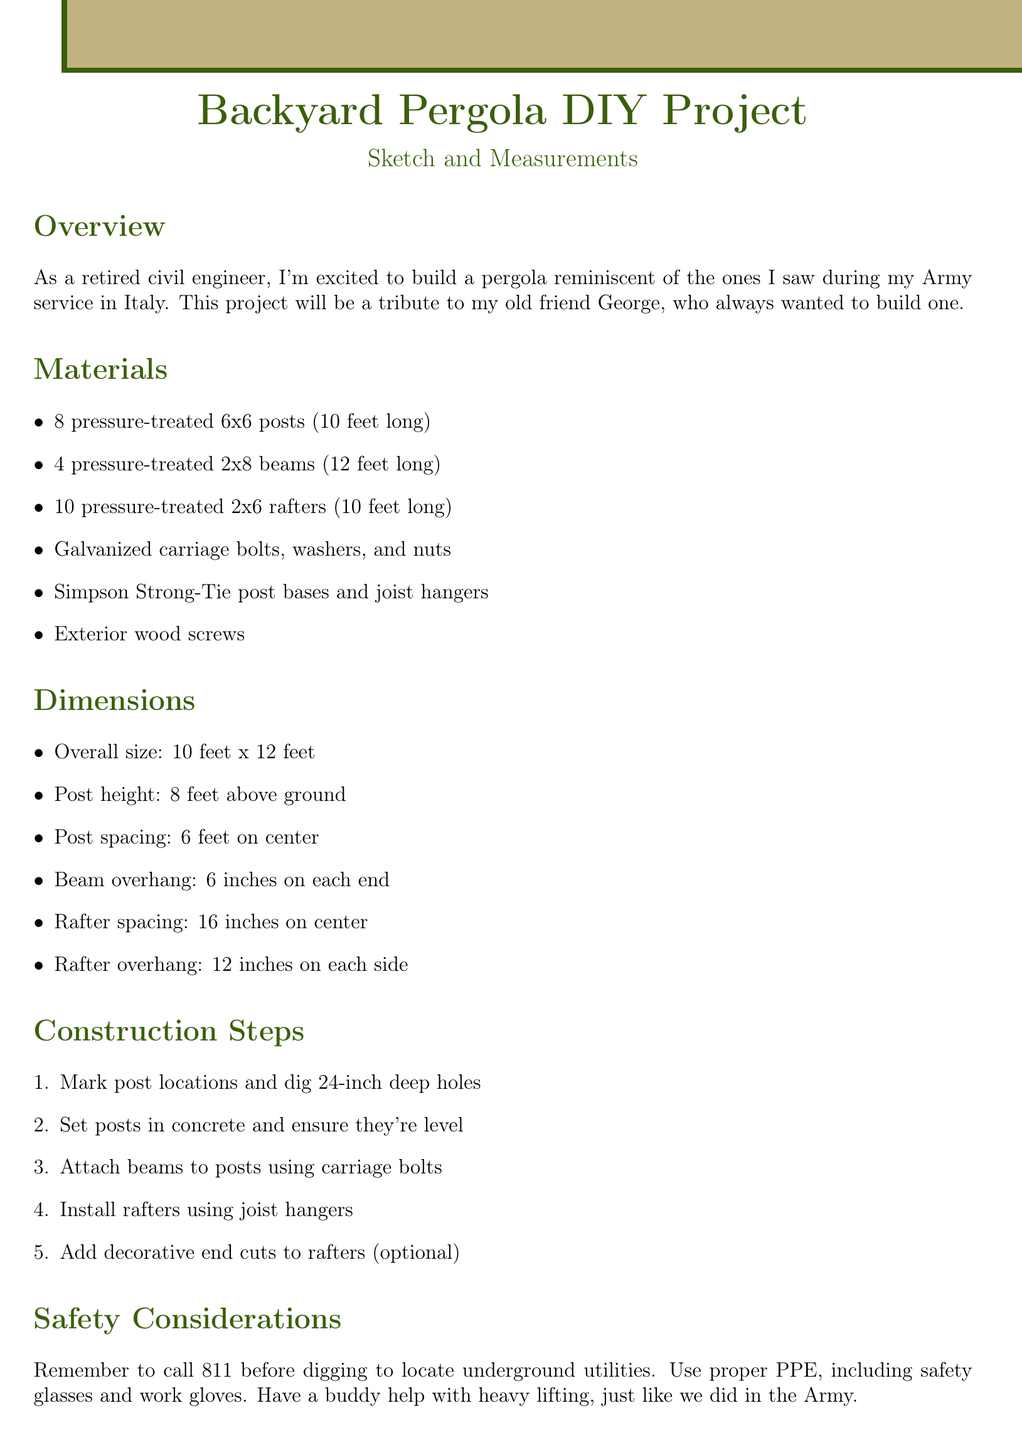What is the tribute in this project? The project is a tribute to the old friend George, who always wanted to build a pergola.
Answer: George How many posts are needed for the pergola? The document states the need for 8 pressure-treated 6x6 posts for construction.
Answer: 8 What is the height of the posts above ground? The height of the posts is specified as 8 feet above ground in the dimensions section.
Answer: 8 feet What is the overall size of the pergola? The overall size is explicitly stated as 10 feet x 12 feet in the dimensions section.
Answer: 10 feet x 12 feet What should be done before digging? The document advises to call 811 before digging to locate underground utilities.
Answer: Call 811 What type of wood is used for the rafters? The construction specifies pressure-treated 2x6 rafters, indicating the type of wood used.
Answer: Pressure-treated What is the overhang for the rafters? The rafter overhang is specified as 12 inches on each side in the dimensions section.
Answer: 12 inches How deep should the post holes be? The construction steps mention digging holes that are 24 inches deep.
Answer: 24 inches What type of connection detail is included in the sketch? The sketch includes a detail of the post-beam connection as per the notes.
Answer: Post-beam connection 